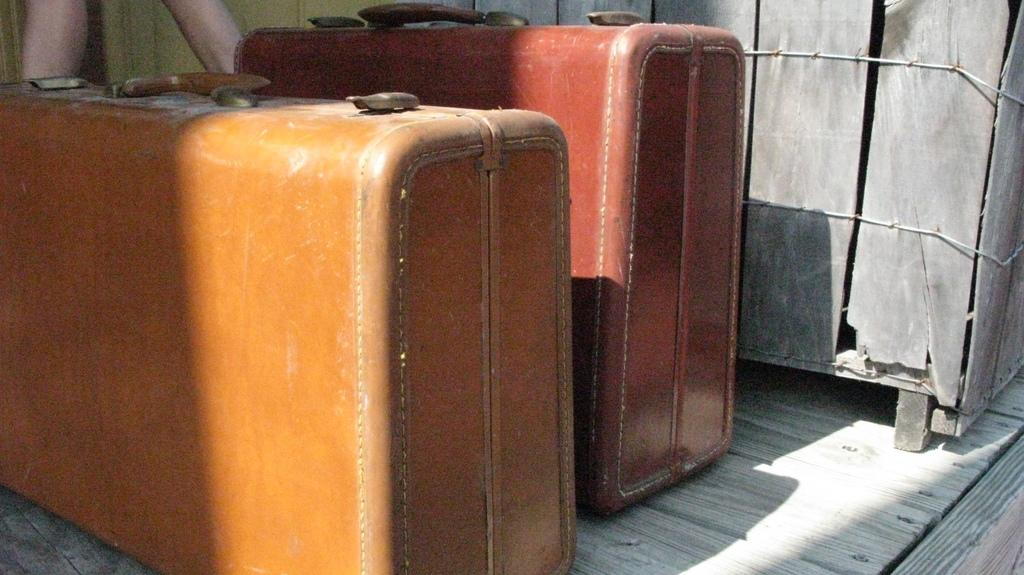How many suitcases are visible in the image? There are two suitcases in the image. What type of quarter is depicted on the suitcase in the image? There is no quarter depicted on the suitcase in the image. What message of hope is written on the suitcase in the image? There is no message of hope written on the suitcase in the image. 